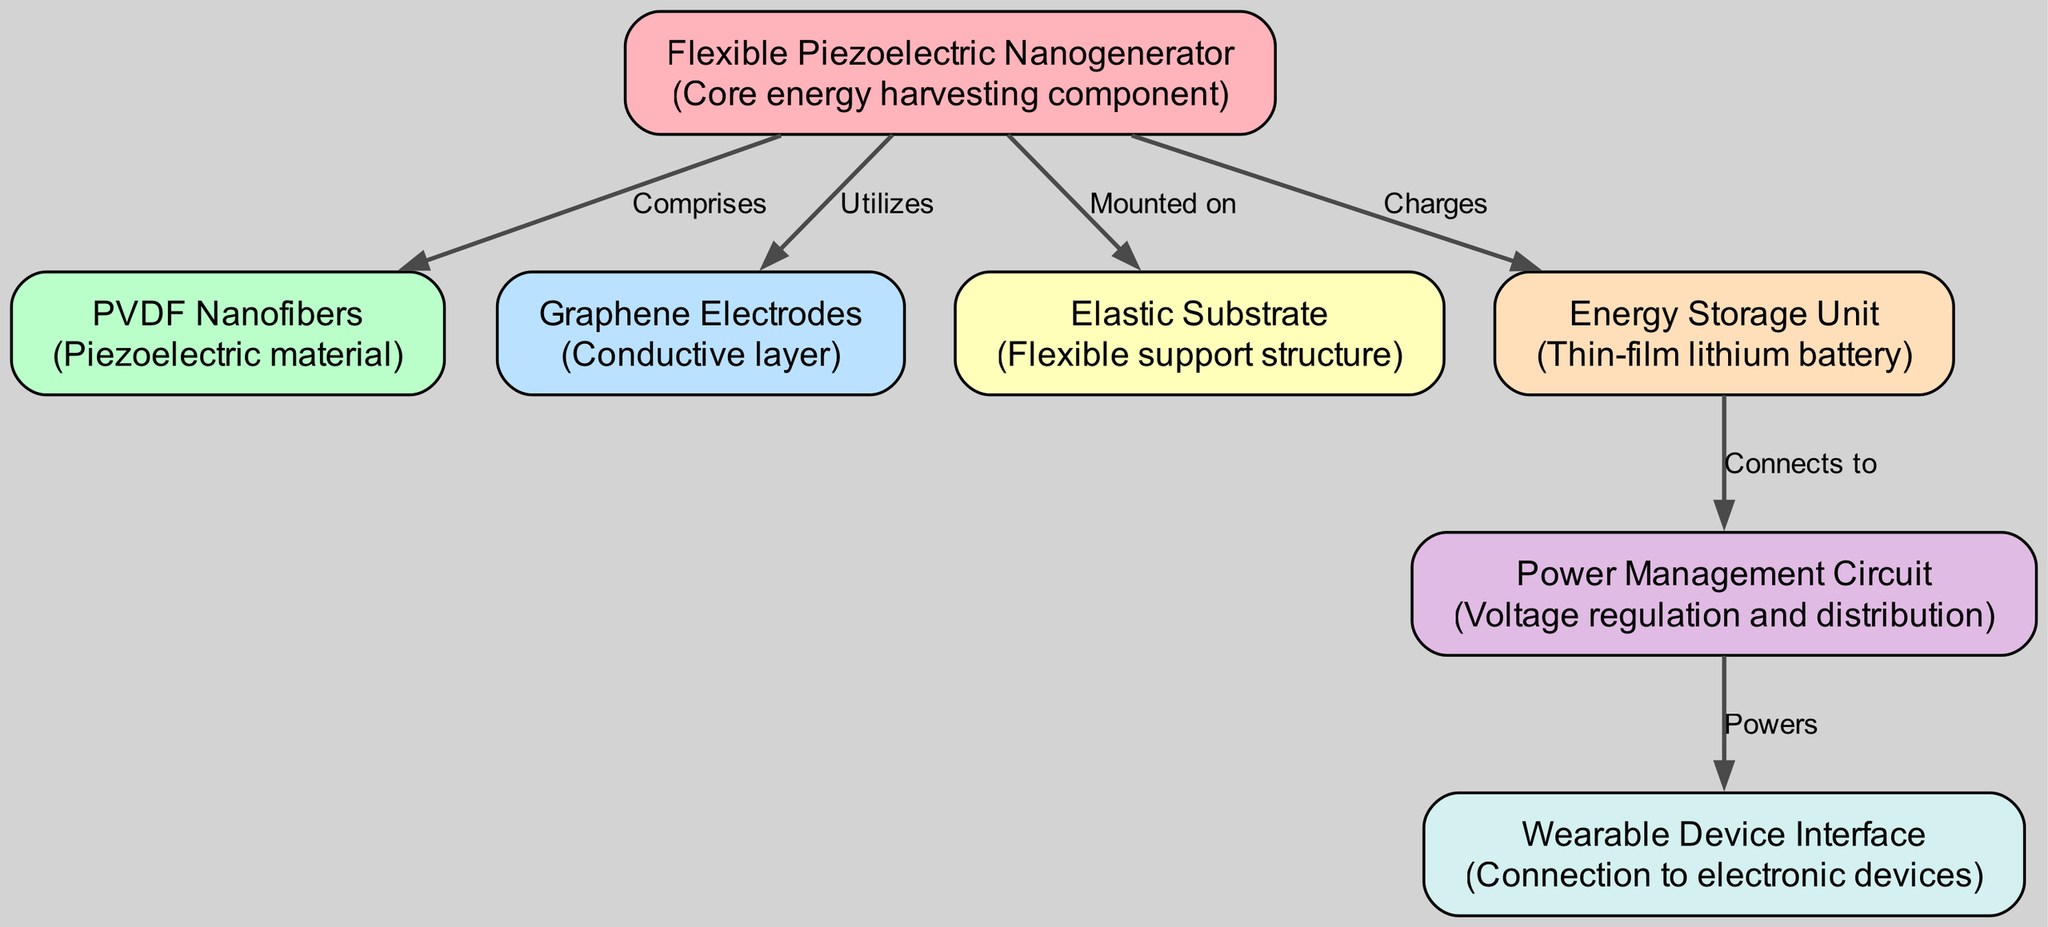What is the core energy harvesting component? The diagram shows that the core energy harvesting component is the "Flexible Piezoelectric Nanogenerator" which is identified as node 1.
Answer: Flexible Piezoelectric Nanogenerator How many nodes are in the diagram? By counting the "nodes" section of the data, we find that there are 7 nodes listed in total.
Answer: 7 What material is utilized in the energy harvesting device? The "Flexible Piezoelectric Nanogenerator" utilizes "Graphene Electrodes" as indicated by the edge from node 1 to node 3 labeled "Utilizes."
Answer: Graphene Electrodes Which component connects to the Power Management Circuit? The edge labeled "Connects to" indicates that the "Energy Storage Unit" (node 5) connects to the "Power Management Circuit" (node 6).
Answer: Energy Storage Unit What is the label for the relationship between the Flexible Piezoelectric Nanogenerator and the PVDF Nanofibers? The relationship is labeled "Comprises" as indicated by the edge from node 1 to node 2.
Answer: Comprises What does the Power Management Circuit do? The flow indicates that the Power Management Circuit "Powers" the Wearable Device Interface, confirming its function.
Answer: Powers Which node is mounted on the Flexible Piezoelectric Nanogenerator? The diagram indicates that "Elastic Substrate" (node 4) is mounted on "Flexible Piezoelectric Nanogenerator" (node 1).
Answer: Elastic Substrate 